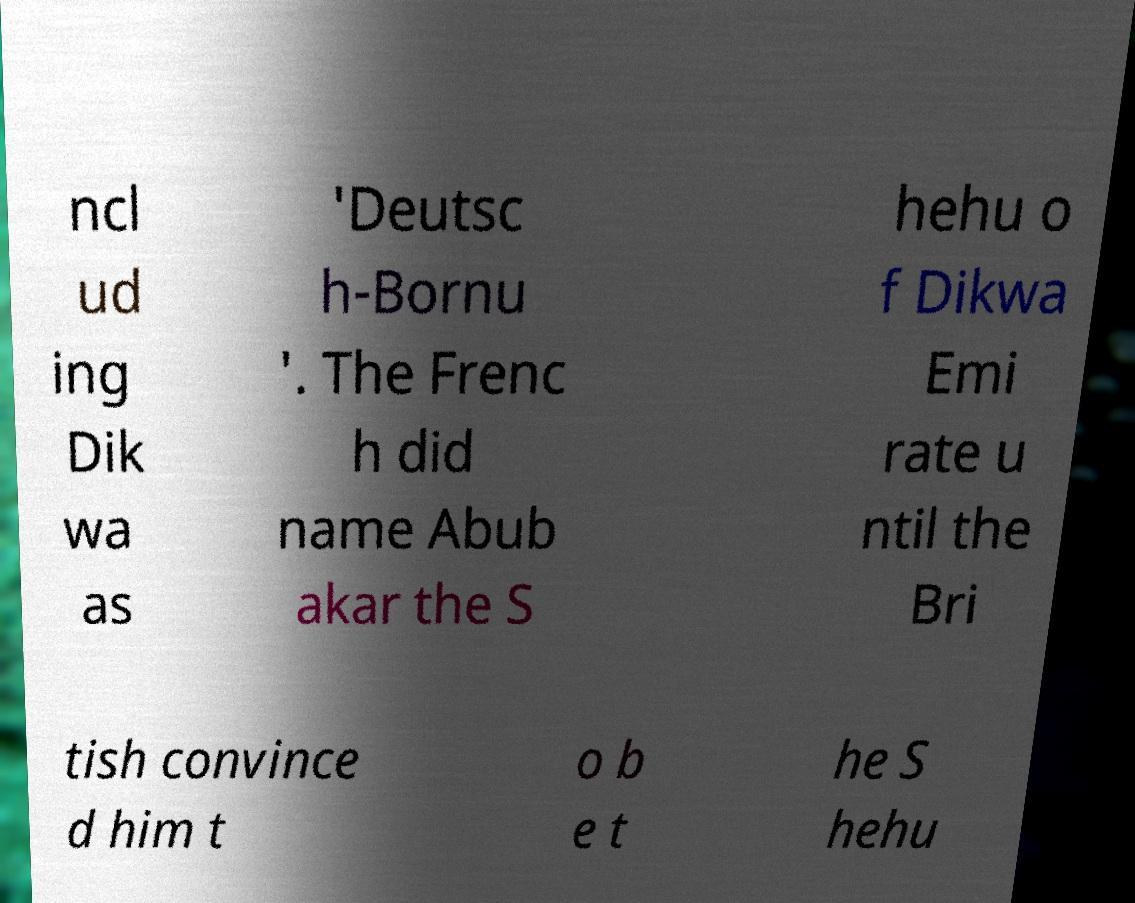Can you read and provide the text displayed in the image?This photo seems to have some interesting text. Can you extract and type it out for me? ncl ud ing Dik wa as 'Deutsc h-Bornu '. The Frenc h did name Abub akar the S hehu o f Dikwa Emi rate u ntil the Bri tish convince d him t o b e t he S hehu 